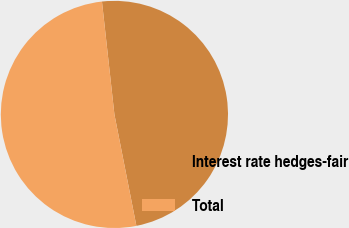<chart> <loc_0><loc_0><loc_500><loc_500><pie_chart><fcel>Interest rate hedges-fair<fcel>Total<nl><fcel>48.65%<fcel>51.35%<nl></chart> 